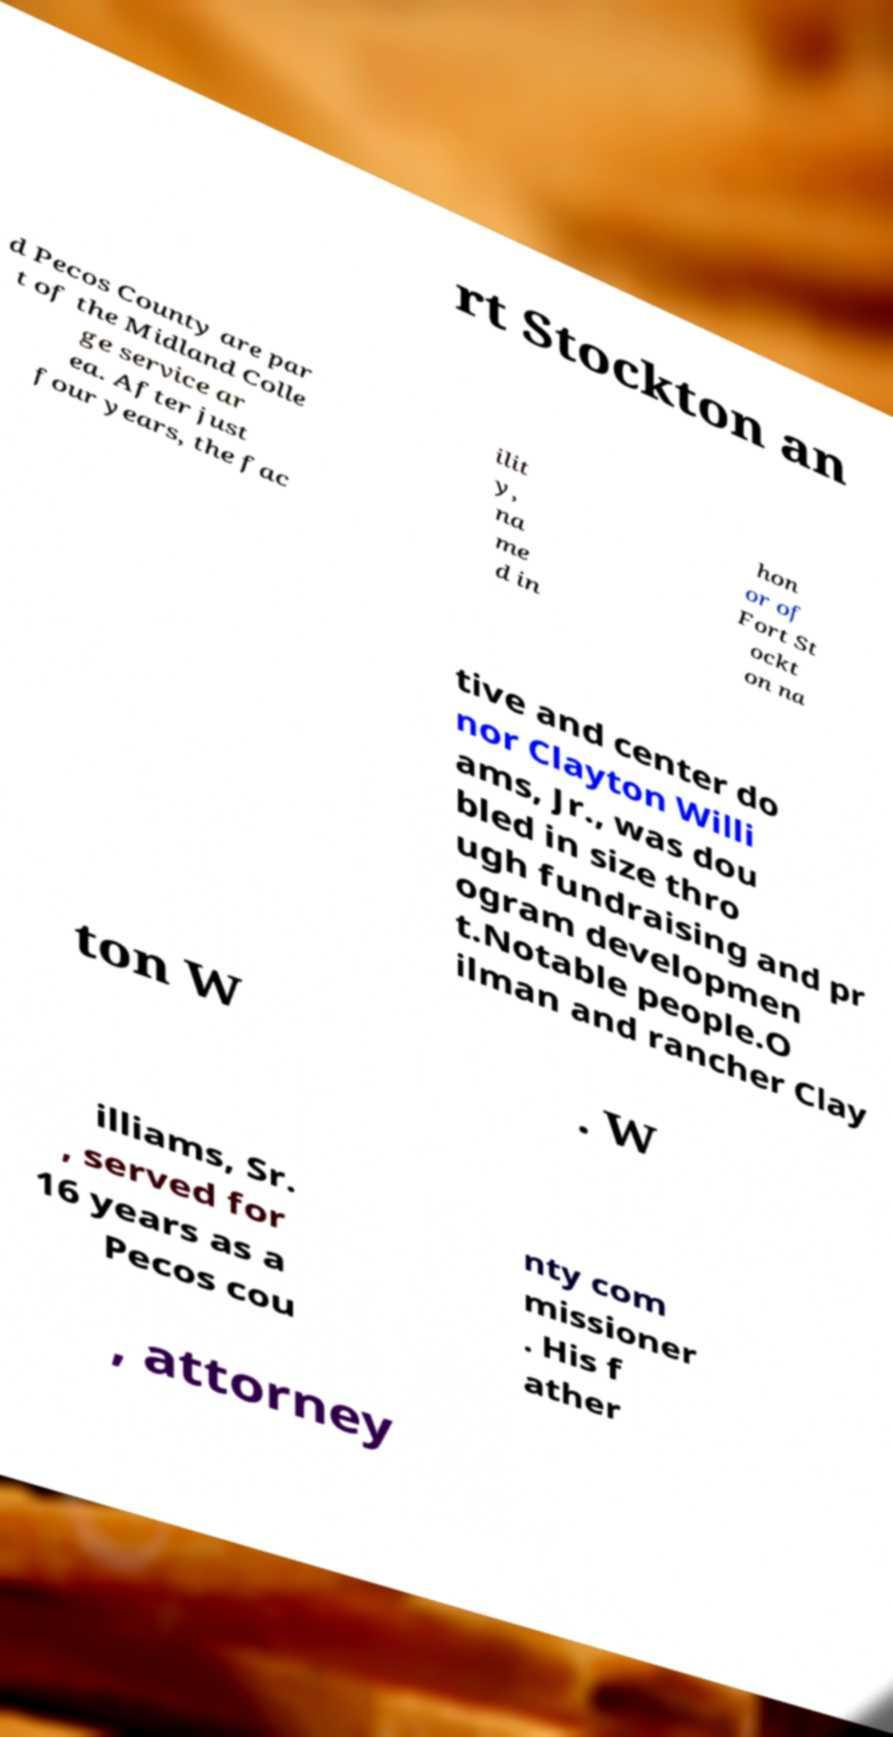For documentation purposes, I need the text within this image transcribed. Could you provide that? rt Stockton an d Pecos County are par t of the Midland Colle ge service ar ea. After just four years, the fac ilit y, na me d in hon or of Fort St ockt on na tive and center do nor Clayton Willi ams, Jr., was dou bled in size thro ugh fundraising and pr ogram developmen t.Notable people.O ilman and rancher Clay ton W . W illiams, Sr. , served for 16 years as a Pecos cou nty com missioner . His f ather , attorney 